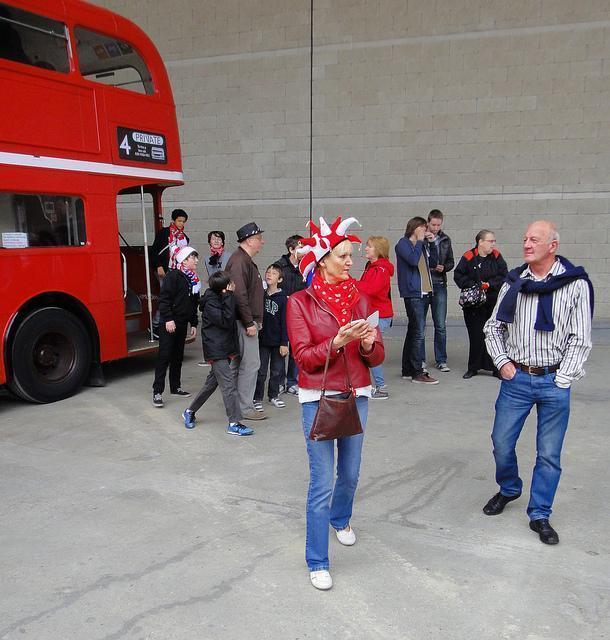What activity do the persons near the bus take part in?
From the following four choices, select the correct answer to address the question.
Options: Harvest, tourism, sales, marketing. Tourism. 